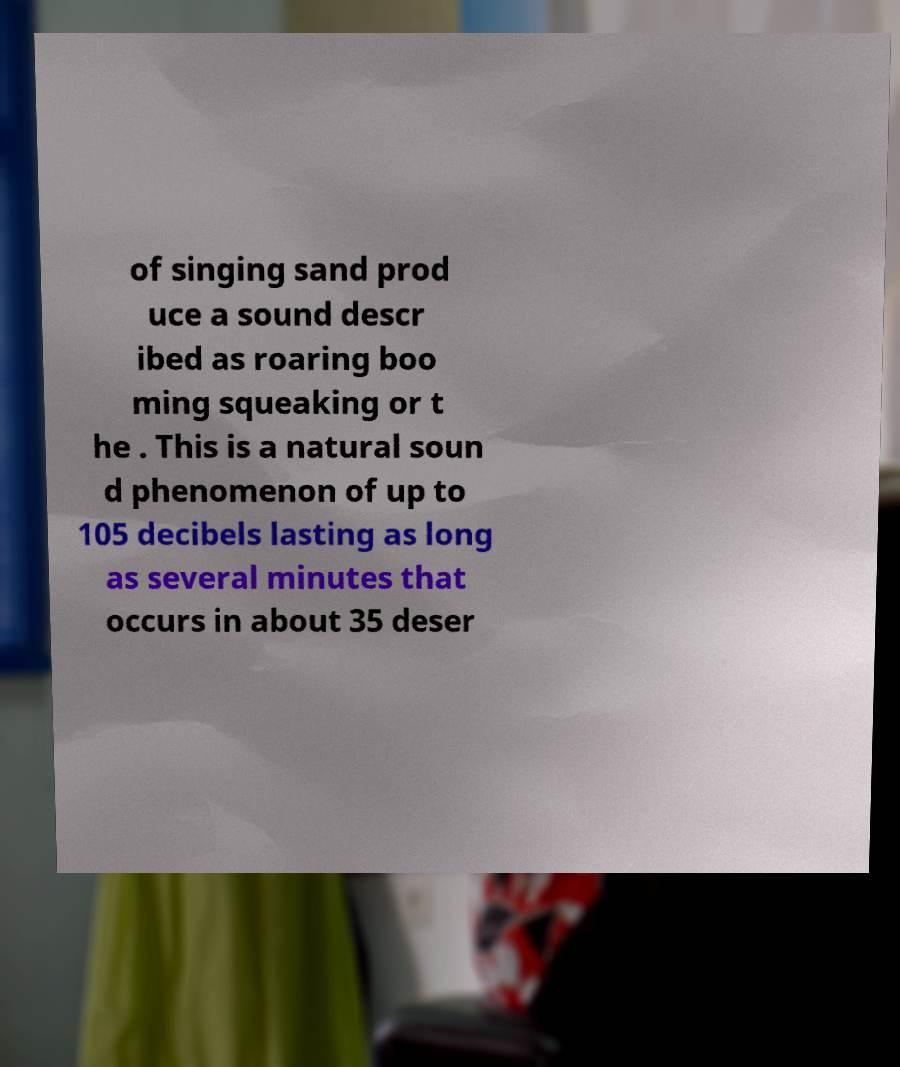Please identify and transcribe the text found in this image. of singing sand prod uce a sound descr ibed as roaring boo ming squeaking or t he . This is a natural soun d phenomenon of up to 105 decibels lasting as long as several minutes that occurs in about 35 deser 